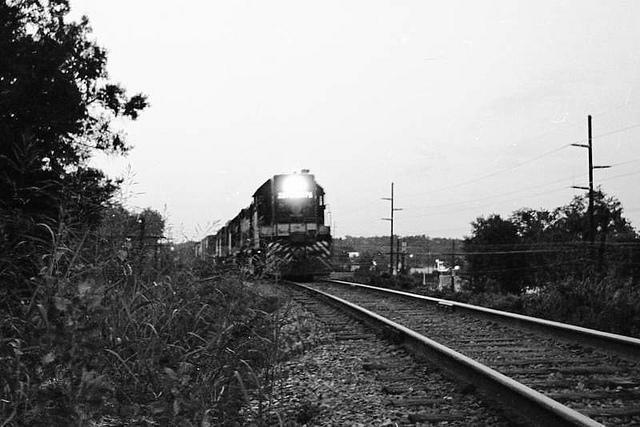How many people are wearing white hats?
Give a very brief answer. 0. 